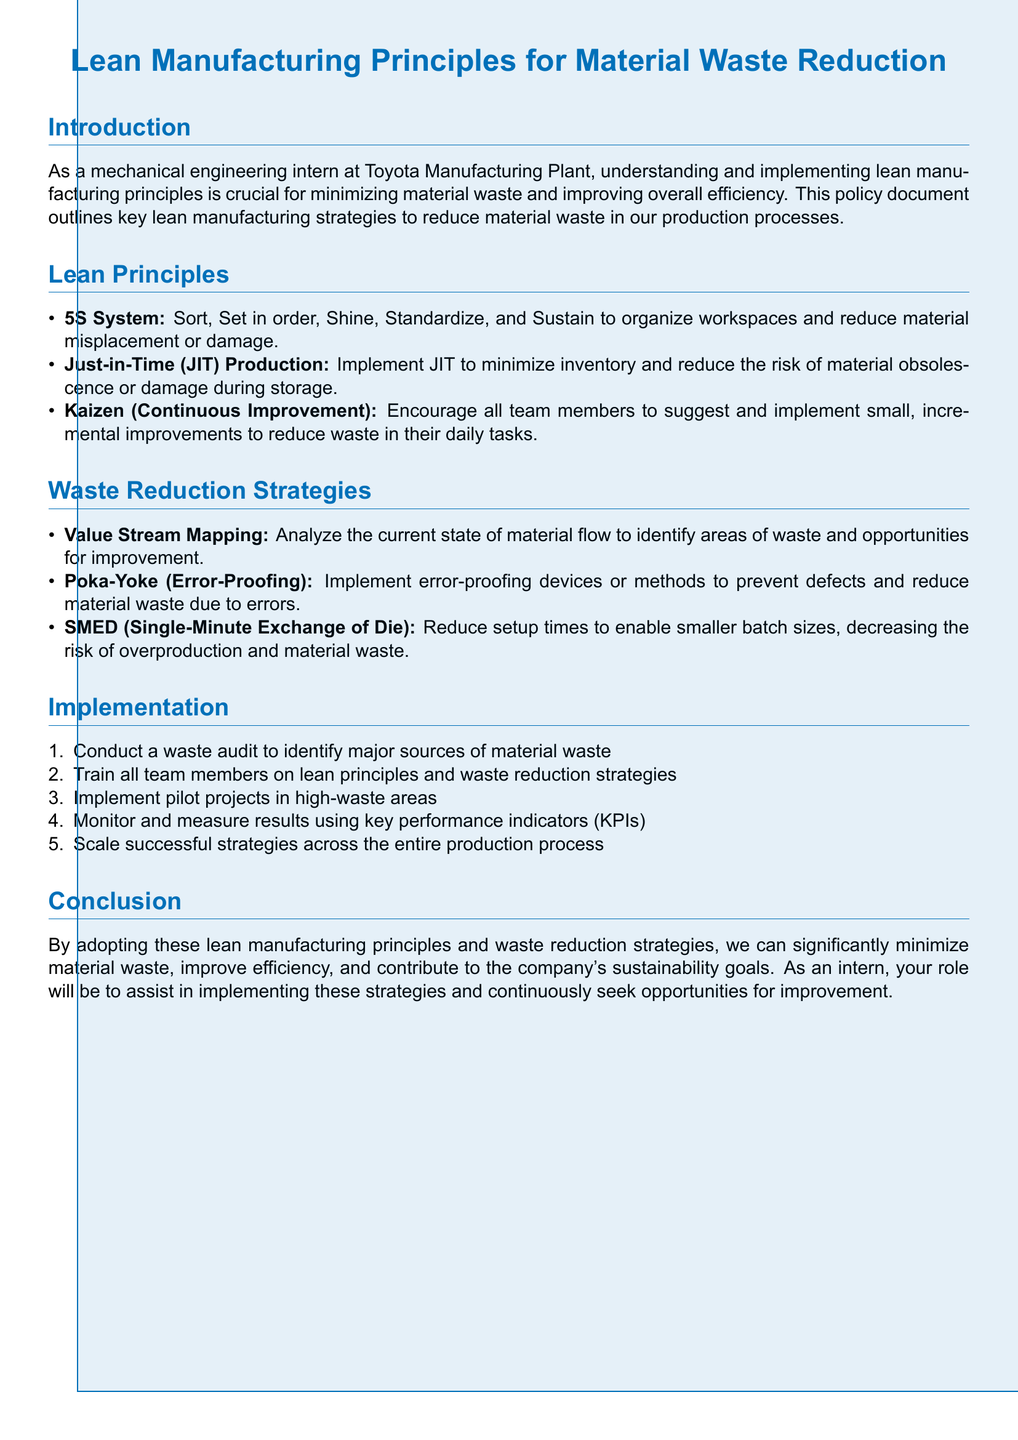What does the 5S System stand for? The 5S System includes five steps for waste reduction: Sort, Set in order, Shine, Standardize, and Sustain.
Answer: Sort, Set in order, Shine, Standardize, Sustain What is the primary focus of Just-in-Time (JIT) Production? JIT production aims to minimize inventory to reduce material obsolescence or damage.
Answer: Minimize inventory What does Kaizen mean in the context of lean principles? Kaizen refers to continuous improvement, encouraging team members to suggest incremental changes.
Answer: Continuous Improvement What method is used to analyze material flow for waste identification? The strategy referred to is Value Stream Mapping, which assesses current material flow to spot waste areas.
Answer: Value Stream Mapping What is the purpose of Poka-Yoke? Poka-Yoke aims to implement error-proofing methods to prevent defects and reduce waste from errors.
Answer: Error-Proofing How many steps are outlined in the Implementation section? The Implementation section has five steps for executing waste reduction strategies.
Answer: Five What key metric is suggested for monitoring progress? Key performance indicators (KPIs) are recommended for tracking monitoring results.
Answer: Key Performance Indicators What is the overarching goal of adopting lean manufacturing principles according to the conclusion? The main goal is to minimize material waste and improve efficiency while supporting sustainability efforts.
Answer: Minimize material waste What is the first action listed in the Implementation section? The first step involves conducting a waste audit to find significant sources of material waste.
Answer: Conduct a waste audit 